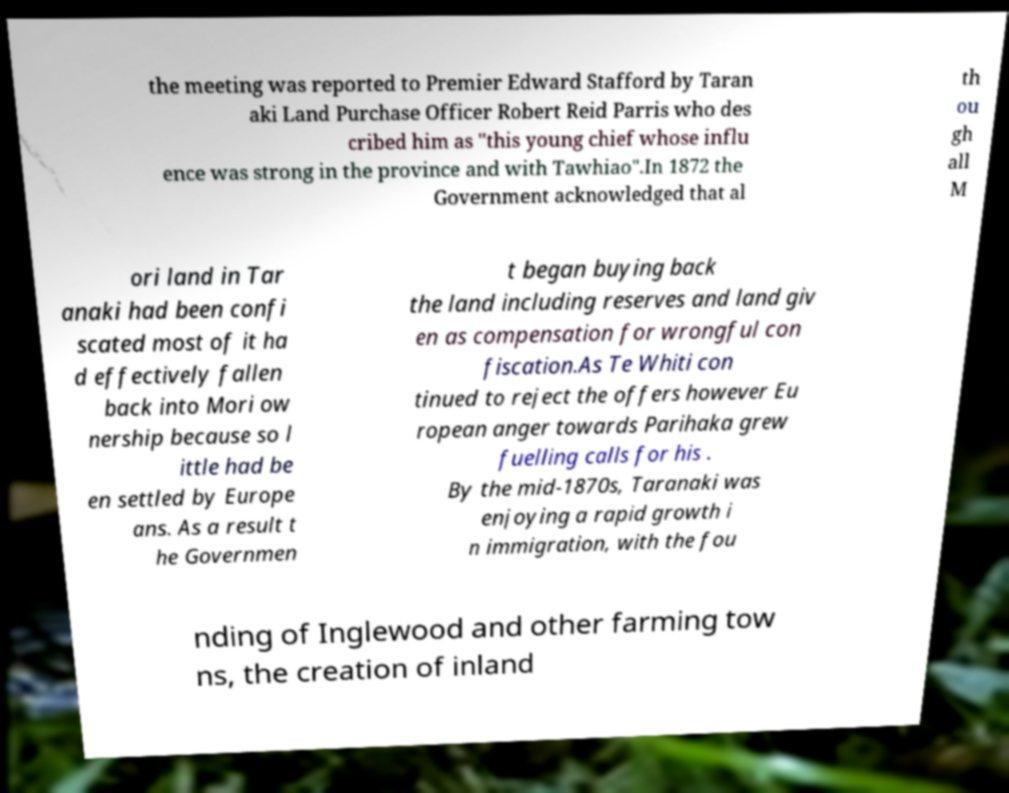There's text embedded in this image that I need extracted. Can you transcribe it verbatim? the meeting was reported to Premier Edward Stafford by Taran aki Land Purchase Officer Robert Reid Parris who des cribed him as "this young chief whose influ ence was strong in the province and with Tawhiao".In 1872 the Government acknowledged that al th ou gh all M ori land in Tar anaki had been confi scated most of it ha d effectively fallen back into Mori ow nership because so l ittle had be en settled by Europe ans. As a result t he Governmen t began buying back the land including reserves and land giv en as compensation for wrongful con fiscation.As Te Whiti con tinued to reject the offers however Eu ropean anger towards Parihaka grew fuelling calls for his . By the mid-1870s, Taranaki was enjoying a rapid growth i n immigration, with the fou nding of Inglewood and other farming tow ns, the creation of inland 